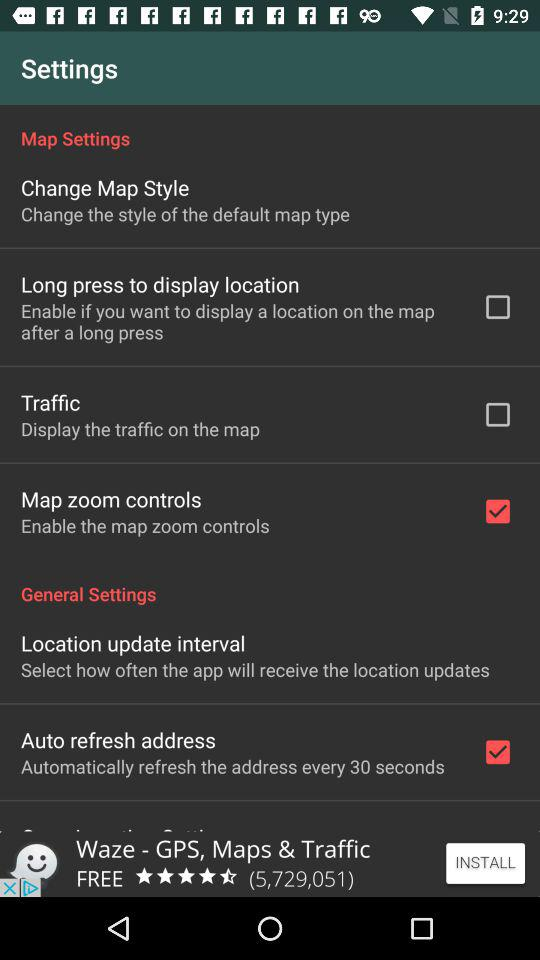In how many seconds does the address automatically refresh? The address automatically refreshes every 30 seconds. 